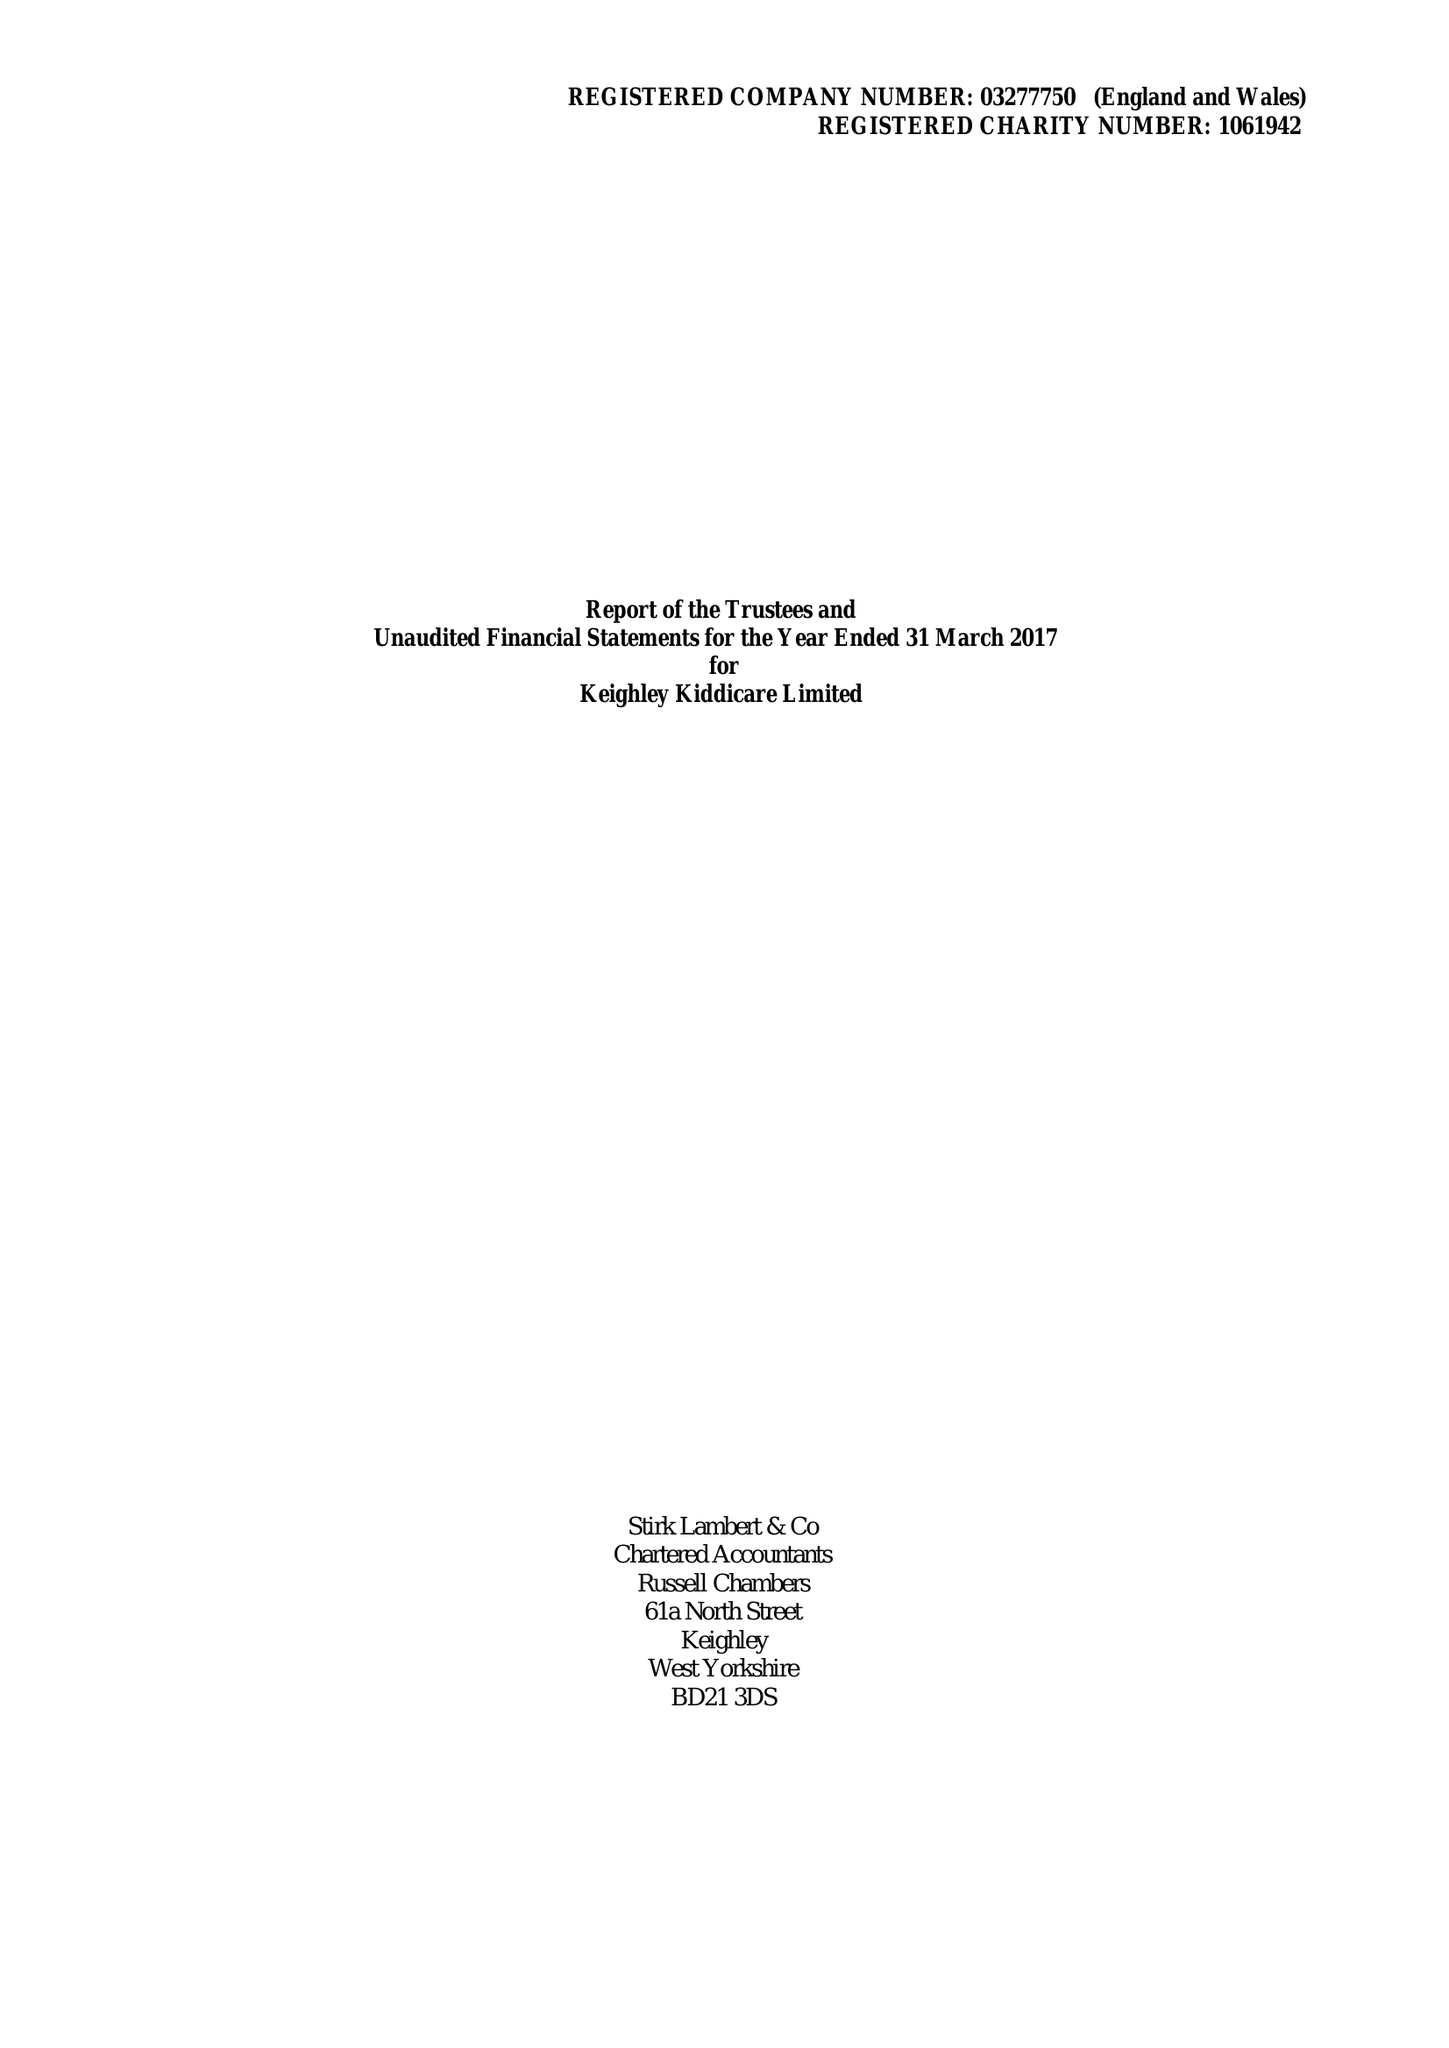What is the value for the charity_name?
Answer the question using a single word or phrase. Keighley Kiddicare Ltd. 